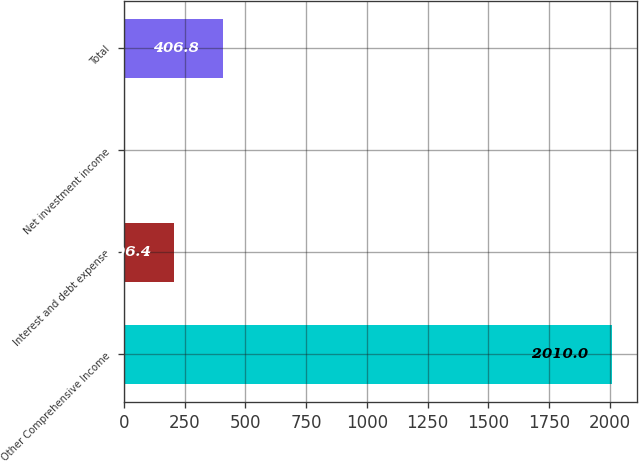Convert chart to OTSL. <chart><loc_0><loc_0><loc_500><loc_500><bar_chart><fcel>Other Comprehensive Income<fcel>Interest and debt expense<fcel>Net investment income<fcel>Total<nl><fcel>2010<fcel>206.4<fcel>6<fcel>406.8<nl></chart> 